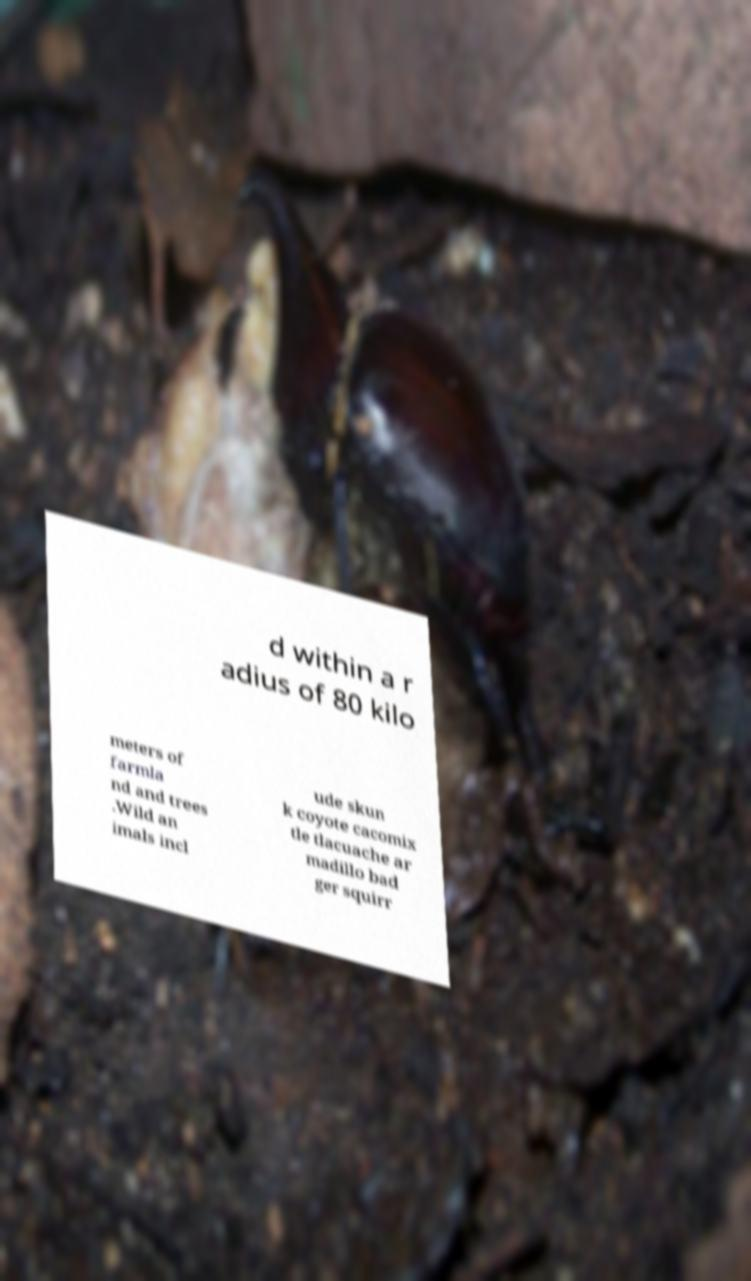Can you read and provide the text displayed in the image?This photo seems to have some interesting text. Can you extract and type it out for me? d within a r adius of 80 kilo meters of farmla nd and trees .Wild an imals incl ude skun k coyote cacomix tle tlacuache ar madillo bad ger squirr 